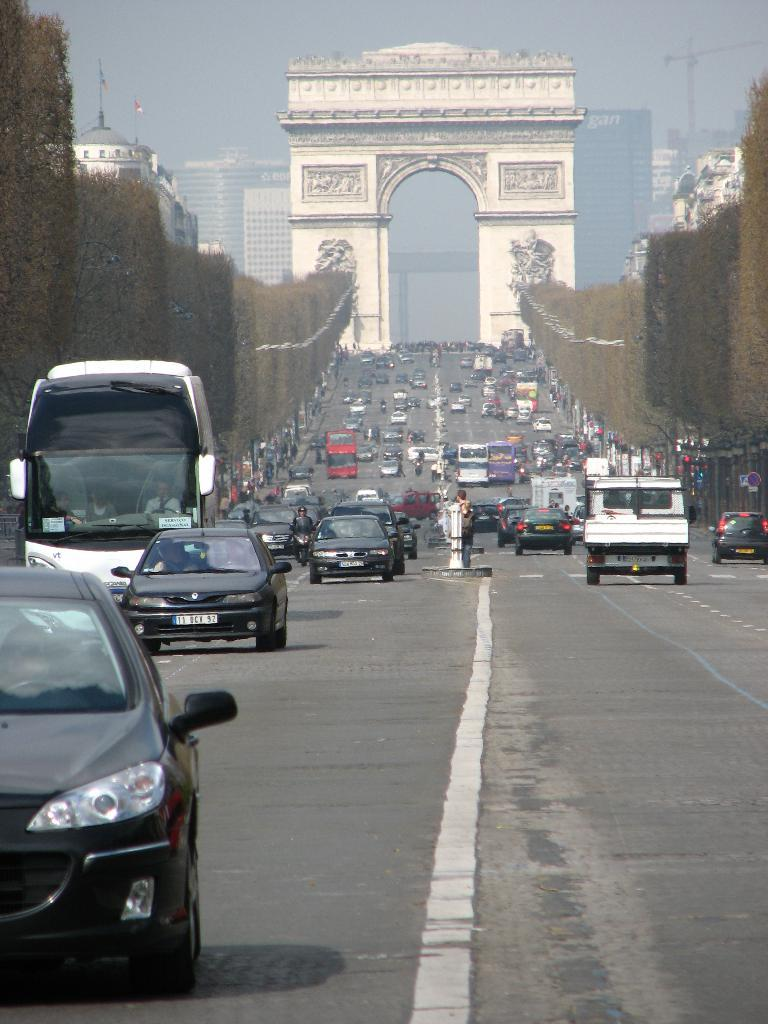What is the main structure in the center of the image? There is an arch in the center of the image. What can be seen at the bottom of the image? There are vehicles on the road at the bottom of the image. Are there any people visible in the image? Yes, there are people visible in the image. What is visible in the background of the image? There are buildings and the sky visible in the background of the image. What type of vegetation is present in the image? There are trees in the image. How many legs can be seen on the match in the image? There is no match present in the image, so it is not possible to determine the number of legs on a match. 